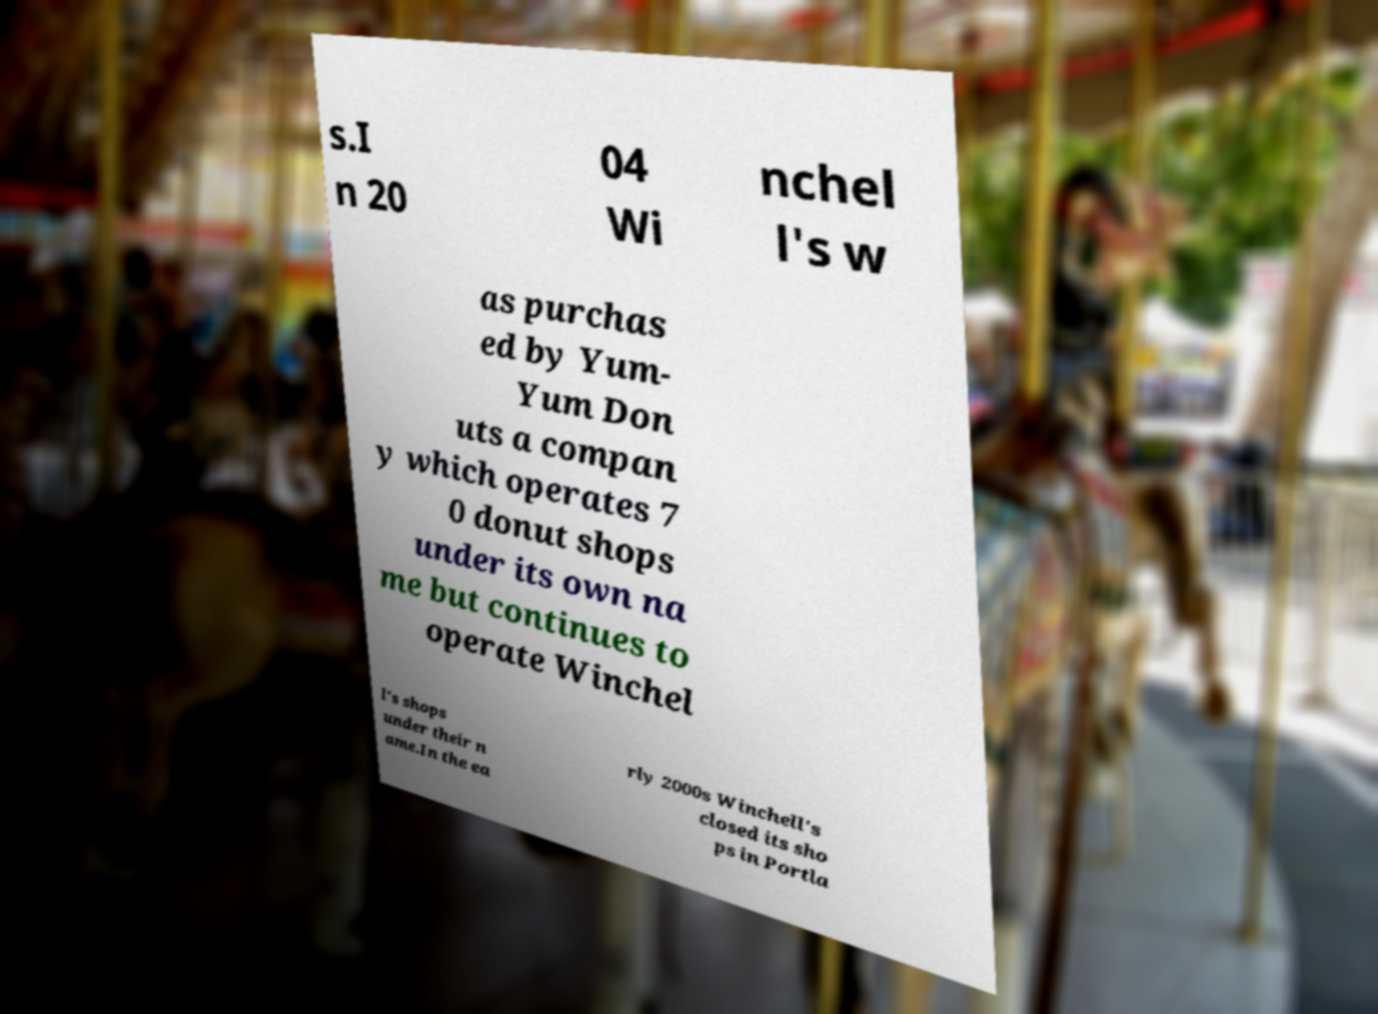What messages or text are displayed in this image? I need them in a readable, typed format. s.I n 20 04 Wi nchel l's w as purchas ed by Yum- Yum Don uts a compan y which operates 7 0 donut shops under its own na me but continues to operate Winchel l's shops under their n ame.In the ea rly 2000s Winchell's closed its sho ps in Portla 